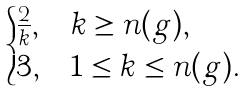Convert formula to latex. <formula><loc_0><loc_0><loc_500><loc_500>\begin{cases} \frac { 2 } { k } , & k \geq n ( g ) , \\ 3 , & 1 \leq k \leq n ( g ) . \end{cases}</formula> 